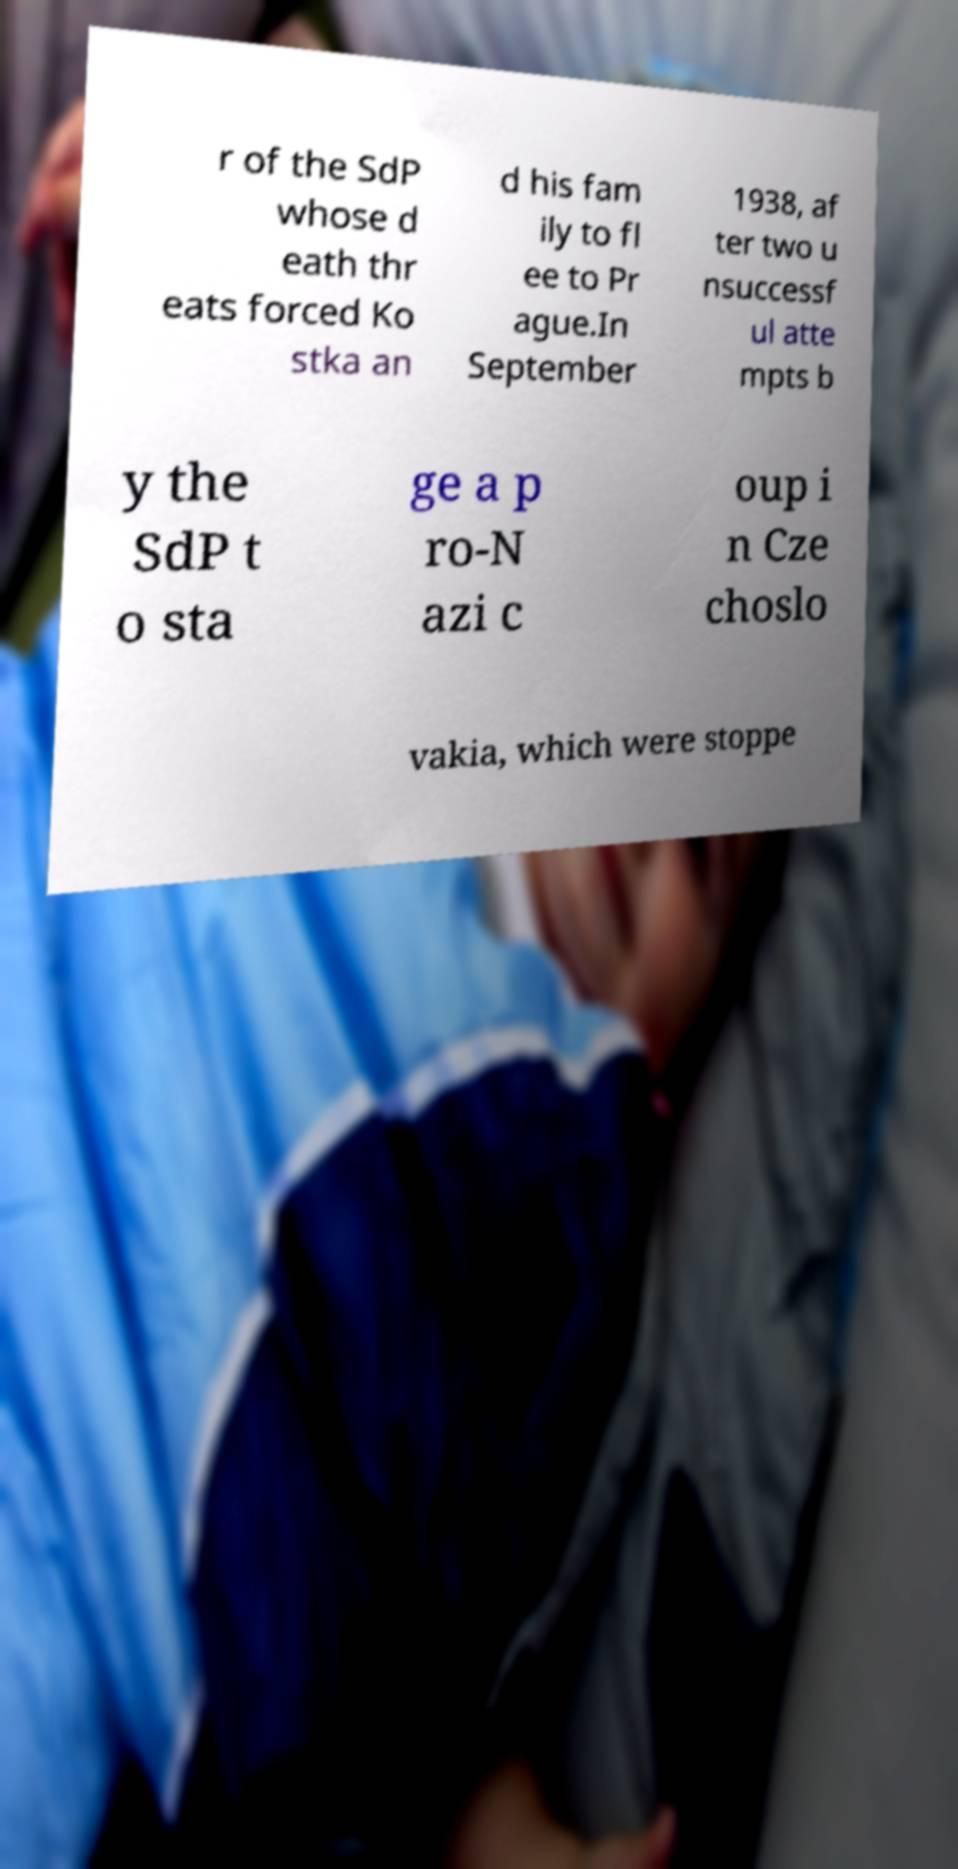I need the written content from this picture converted into text. Can you do that? r of the SdP whose d eath thr eats forced Ko stka an d his fam ily to fl ee to Pr ague.In September 1938, af ter two u nsuccessf ul atte mpts b y the SdP t o sta ge a p ro-N azi c oup i n Cze choslo vakia, which were stoppe 